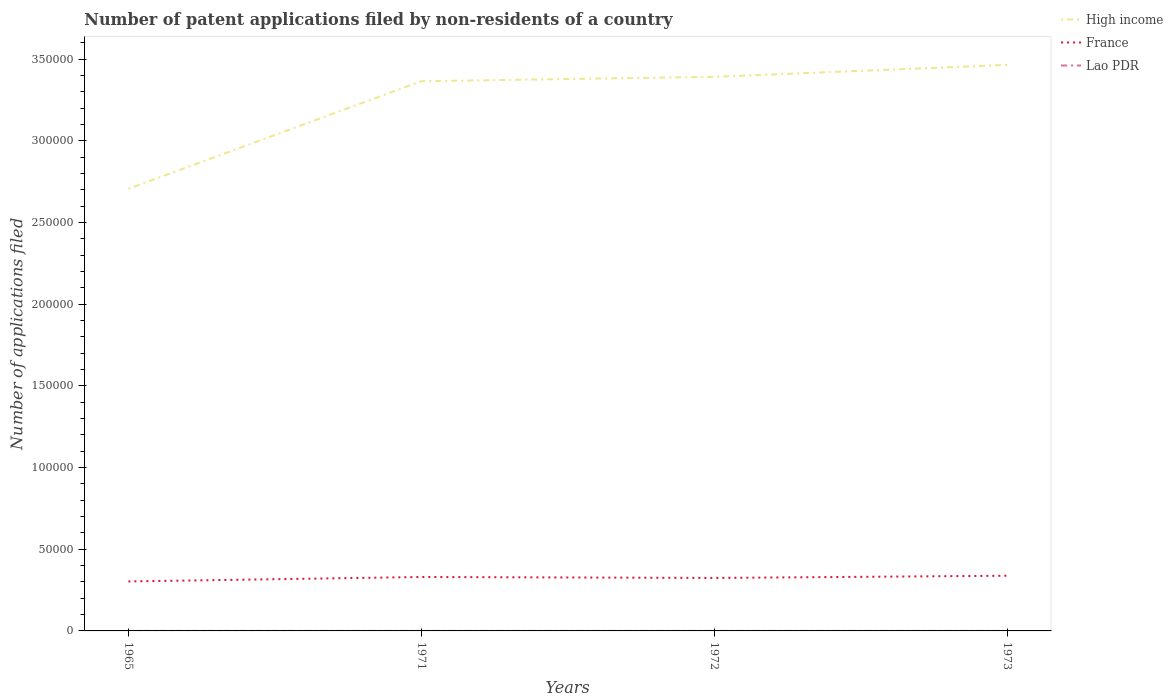Across all years, what is the maximum number of applications filed in Lao PDR?
Give a very brief answer. 4. What is the total number of applications filed in France in the graph?
Make the answer very short. 586. What is the difference between the highest and the second highest number of applications filed in France?
Ensure brevity in your answer.  3492. Is the number of applications filed in High income strictly greater than the number of applications filed in France over the years?
Offer a very short reply. No. How many legend labels are there?
Offer a very short reply. 3. What is the title of the graph?
Provide a succinct answer. Number of patent applications filed by non-residents of a country. What is the label or title of the Y-axis?
Offer a very short reply. Number of applications filed. What is the Number of applications filed in High income in 1965?
Your answer should be compact. 2.71e+05. What is the Number of applications filed of France in 1965?
Your answer should be very brief. 3.03e+04. What is the Number of applications filed in Lao PDR in 1965?
Give a very brief answer. 22. What is the Number of applications filed of High income in 1971?
Offer a terse response. 3.36e+05. What is the Number of applications filed in France in 1971?
Offer a very short reply. 3.30e+04. What is the Number of applications filed of High income in 1972?
Your response must be concise. 3.39e+05. What is the Number of applications filed of France in 1972?
Ensure brevity in your answer.  3.24e+04. What is the Number of applications filed of High income in 1973?
Keep it short and to the point. 3.46e+05. What is the Number of applications filed in France in 1973?
Provide a succinct answer. 3.38e+04. What is the Number of applications filed of Lao PDR in 1973?
Provide a short and direct response. 4. Across all years, what is the maximum Number of applications filed in High income?
Your answer should be very brief. 3.46e+05. Across all years, what is the maximum Number of applications filed in France?
Ensure brevity in your answer.  3.38e+04. Across all years, what is the minimum Number of applications filed in High income?
Provide a short and direct response. 2.71e+05. Across all years, what is the minimum Number of applications filed of France?
Your answer should be very brief. 3.03e+04. Across all years, what is the minimum Number of applications filed of Lao PDR?
Provide a succinct answer. 4. What is the total Number of applications filed of High income in the graph?
Give a very brief answer. 1.29e+06. What is the total Number of applications filed of France in the graph?
Ensure brevity in your answer.  1.29e+05. What is the total Number of applications filed in Lao PDR in the graph?
Provide a short and direct response. 46. What is the difference between the Number of applications filed in High income in 1965 and that in 1971?
Your answer should be very brief. -6.58e+04. What is the difference between the Number of applications filed in France in 1965 and that in 1971?
Offer a terse response. -2725. What is the difference between the Number of applications filed of Lao PDR in 1965 and that in 1971?
Your answer should be compact. 14. What is the difference between the Number of applications filed in High income in 1965 and that in 1972?
Offer a terse response. -6.85e+04. What is the difference between the Number of applications filed of France in 1965 and that in 1972?
Make the answer very short. -2139. What is the difference between the Number of applications filed of Lao PDR in 1965 and that in 1972?
Your answer should be very brief. 10. What is the difference between the Number of applications filed in High income in 1965 and that in 1973?
Provide a succinct answer. -7.58e+04. What is the difference between the Number of applications filed in France in 1965 and that in 1973?
Offer a terse response. -3492. What is the difference between the Number of applications filed in High income in 1971 and that in 1972?
Make the answer very short. -2684. What is the difference between the Number of applications filed of France in 1971 and that in 1972?
Keep it short and to the point. 586. What is the difference between the Number of applications filed in High income in 1971 and that in 1973?
Keep it short and to the point. -9999. What is the difference between the Number of applications filed of France in 1971 and that in 1973?
Provide a succinct answer. -767. What is the difference between the Number of applications filed in Lao PDR in 1971 and that in 1973?
Ensure brevity in your answer.  4. What is the difference between the Number of applications filed of High income in 1972 and that in 1973?
Make the answer very short. -7315. What is the difference between the Number of applications filed of France in 1972 and that in 1973?
Offer a very short reply. -1353. What is the difference between the Number of applications filed in High income in 1965 and the Number of applications filed in France in 1971?
Ensure brevity in your answer.  2.38e+05. What is the difference between the Number of applications filed in High income in 1965 and the Number of applications filed in Lao PDR in 1971?
Your response must be concise. 2.71e+05. What is the difference between the Number of applications filed in France in 1965 and the Number of applications filed in Lao PDR in 1971?
Give a very brief answer. 3.03e+04. What is the difference between the Number of applications filed in High income in 1965 and the Number of applications filed in France in 1972?
Give a very brief answer. 2.38e+05. What is the difference between the Number of applications filed in High income in 1965 and the Number of applications filed in Lao PDR in 1972?
Your response must be concise. 2.71e+05. What is the difference between the Number of applications filed of France in 1965 and the Number of applications filed of Lao PDR in 1972?
Offer a terse response. 3.03e+04. What is the difference between the Number of applications filed of High income in 1965 and the Number of applications filed of France in 1973?
Ensure brevity in your answer.  2.37e+05. What is the difference between the Number of applications filed of High income in 1965 and the Number of applications filed of Lao PDR in 1973?
Provide a short and direct response. 2.71e+05. What is the difference between the Number of applications filed in France in 1965 and the Number of applications filed in Lao PDR in 1973?
Make the answer very short. 3.03e+04. What is the difference between the Number of applications filed in High income in 1971 and the Number of applications filed in France in 1972?
Make the answer very short. 3.04e+05. What is the difference between the Number of applications filed of High income in 1971 and the Number of applications filed of Lao PDR in 1972?
Make the answer very short. 3.36e+05. What is the difference between the Number of applications filed in France in 1971 and the Number of applications filed in Lao PDR in 1972?
Give a very brief answer. 3.30e+04. What is the difference between the Number of applications filed of High income in 1971 and the Number of applications filed of France in 1973?
Your answer should be very brief. 3.03e+05. What is the difference between the Number of applications filed of High income in 1971 and the Number of applications filed of Lao PDR in 1973?
Offer a very short reply. 3.36e+05. What is the difference between the Number of applications filed in France in 1971 and the Number of applications filed in Lao PDR in 1973?
Your answer should be compact. 3.30e+04. What is the difference between the Number of applications filed in High income in 1972 and the Number of applications filed in France in 1973?
Offer a very short reply. 3.05e+05. What is the difference between the Number of applications filed of High income in 1972 and the Number of applications filed of Lao PDR in 1973?
Ensure brevity in your answer.  3.39e+05. What is the difference between the Number of applications filed of France in 1972 and the Number of applications filed of Lao PDR in 1973?
Keep it short and to the point. 3.24e+04. What is the average Number of applications filed of High income per year?
Offer a terse response. 3.23e+05. What is the average Number of applications filed of France per year?
Offer a very short reply. 3.24e+04. What is the average Number of applications filed of Lao PDR per year?
Your answer should be very brief. 11.5. In the year 1965, what is the difference between the Number of applications filed of High income and Number of applications filed of France?
Provide a succinct answer. 2.40e+05. In the year 1965, what is the difference between the Number of applications filed of High income and Number of applications filed of Lao PDR?
Ensure brevity in your answer.  2.71e+05. In the year 1965, what is the difference between the Number of applications filed in France and Number of applications filed in Lao PDR?
Offer a very short reply. 3.03e+04. In the year 1971, what is the difference between the Number of applications filed of High income and Number of applications filed of France?
Ensure brevity in your answer.  3.03e+05. In the year 1971, what is the difference between the Number of applications filed in High income and Number of applications filed in Lao PDR?
Your answer should be very brief. 3.36e+05. In the year 1971, what is the difference between the Number of applications filed of France and Number of applications filed of Lao PDR?
Make the answer very short. 3.30e+04. In the year 1972, what is the difference between the Number of applications filed of High income and Number of applications filed of France?
Your answer should be very brief. 3.07e+05. In the year 1972, what is the difference between the Number of applications filed in High income and Number of applications filed in Lao PDR?
Ensure brevity in your answer.  3.39e+05. In the year 1972, what is the difference between the Number of applications filed of France and Number of applications filed of Lao PDR?
Give a very brief answer. 3.24e+04. In the year 1973, what is the difference between the Number of applications filed of High income and Number of applications filed of France?
Make the answer very short. 3.13e+05. In the year 1973, what is the difference between the Number of applications filed in High income and Number of applications filed in Lao PDR?
Your response must be concise. 3.46e+05. In the year 1973, what is the difference between the Number of applications filed of France and Number of applications filed of Lao PDR?
Give a very brief answer. 3.38e+04. What is the ratio of the Number of applications filed of High income in 1965 to that in 1971?
Your response must be concise. 0.8. What is the ratio of the Number of applications filed in France in 1965 to that in 1971?
Give a very brief answer. 0.92. What is the ratio of the Number of applications filed of Lao PDR in 1965 to that in 1971?
Make the answer very short. 2.75. What is the ratio of the Number of applications filed in High income in 1965 to that in 1972?
Ensure brevity in your answer.  0.8. What is the ratio of the Number of applications filed of France in 1965 to that in 1972?
Offer a terse response. 0.93. What is the ratio of the Number of applications filed in Lao PDR in 1965 to that in 1972?
Your answer should be very brief. 1.83. What is the ratio of the Number of applications filed of High income in 1965 to that in 1973?
Keep it short and to the point. 0.78. What is the ratio of the Number of applications filed of France in 1965 to that in 1973?
Offer a very short reply. 0.9. What is the ratio of the Number of applications filed of Lao PDR in 1965 to that in 1973?
Ensure brevity in your answer.  5.5. What is the ratio of the Number of applications filed in France in 1971 to that in 1972?
Offer a very short reply. 1.02. What is the ratio of the Number of applications filed in High income in 1971 to that in 1973?
Your answer should be very brief. 0.97. What is the ratio of the Number of applications filed of France in 1971 to that in 1973?
Ensure brevity in your answer.  0.98. What is the ratio of the Number of applications filed of High income in 1972 to that in 1973?
Offer a terse response. 0.98. What is the ratio of the Number of applications filed of France in 1972 to that in 1973?
Make the answer very short. 0.96. What is the difference between the highest and the second highest Number of applications filed of High income?
Give a very brief answer. 7315. What is the difference between the highest and the second highest Number of applications filed in France?
Give a very brief answer. 767. What is the difference between the highest and the lowest Number of applications filed in High income?
Offer a terse response. 7.58e+04. What is the difference between the highest and the lowest Number of applications filed of France?
Make the answer very short. 3492. 